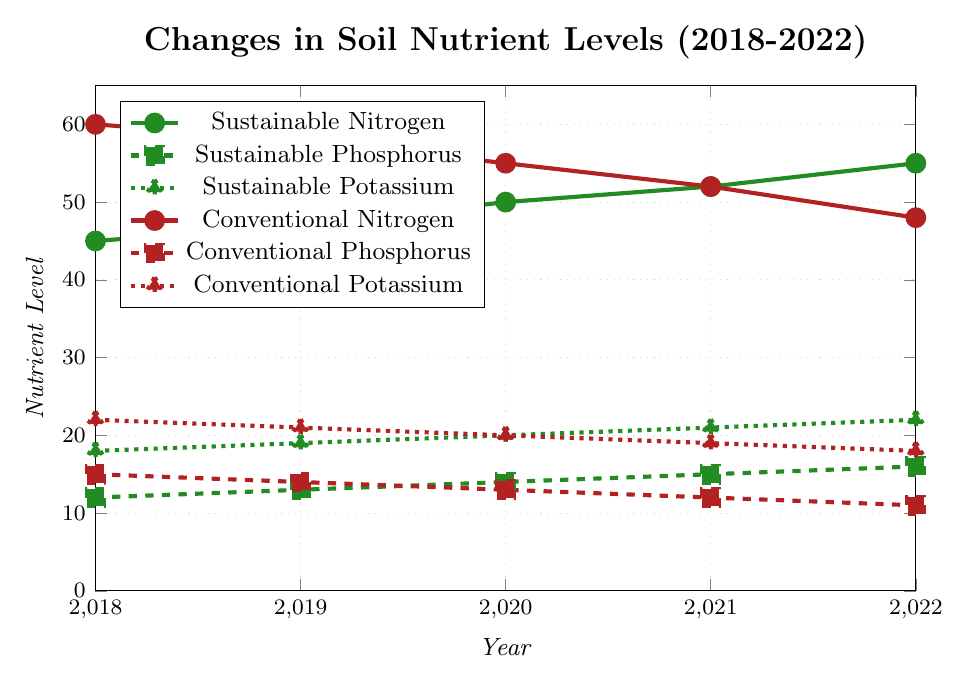How did the nitrogen levels in sustainable farming change from 2018 to 2022? To find this, we look at the sustainable nitrogen data points between 2018 and 2022: in 2018 it was 45, and in 2022 it increased to 55.
Answer: Increased by 10 Which farming method had higher phosphorus levels in 2020, and by how much? For 2020, sustainable phosphorus was at 14 and conventional phosphorus was at 13. The difference is 1.
Answer: Sustainable by 1 What is the overall trend of potassium levels for conventional farming from 2018 to 2022? Observing the conventional potassium values, they decrease from 22 in 2018 to 18 in 2022.
Answer: Decreasing Compare the changes in nitrogen levels for both farming methods over the 5-year period. Which method saw a greater change? Sustainable nitrogen levels increased from 45 to 55 (10 units), while conventional nitrogen levels decreased from 60 to 48 (12 units). The change is greater in conventional farming.
Answer: Conventional saw a greater change (12 units) What was the average level of sustainable phosphorus from 2018 to 2022? Average is calculated by summing the values (12+13+14+15+16) = 70, then dividing by number of years (5). 70/5 = 14.
Answer: 14 By how much did potassium levels decrease in conventional farms over the period? In 2018 the potassium level was 22, and in 2022 it was 18. The decrease is 22 - 18 = 4.
Answer: Decreased by 4 Which year did sustainable nitrogen first surpass 50 units? Sustainable nitrogen reached 50 units in 2020.
Answer: 2020 Assess the changes in phosphorus levels in sustainable farming from 2018 to 2019. From 2018's value of 12 to 2019's value of 13, the phosphorus levels in sustainable farming increased by 1.
Answer: Increased by 1 Compare the trends in nitrogen levels for both farming systems from 2018 to 2022 using the colors shown in the chart. In the chart, the green line represents sustainable nitrogen levels which show an increasing trend, while the red line for conventional nitrogen levels shows a decreasing trend.
Answer: Increasing (sustainable), Decreasing (conventional) What is the ratio of sustainable nitrogen levels to conventional nitrogen levels in 2021? Sustainable nitrogen is 52 and conventional nitrogen is 52 in 2021. The ratio is 52/52 which simplifies to 1.
Answer: 1 